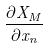<formula> <loc_0><loc_0><loc_500><loc_500>\frac { \partial X _ { M } } { \partial x _ { n } }</formula> 